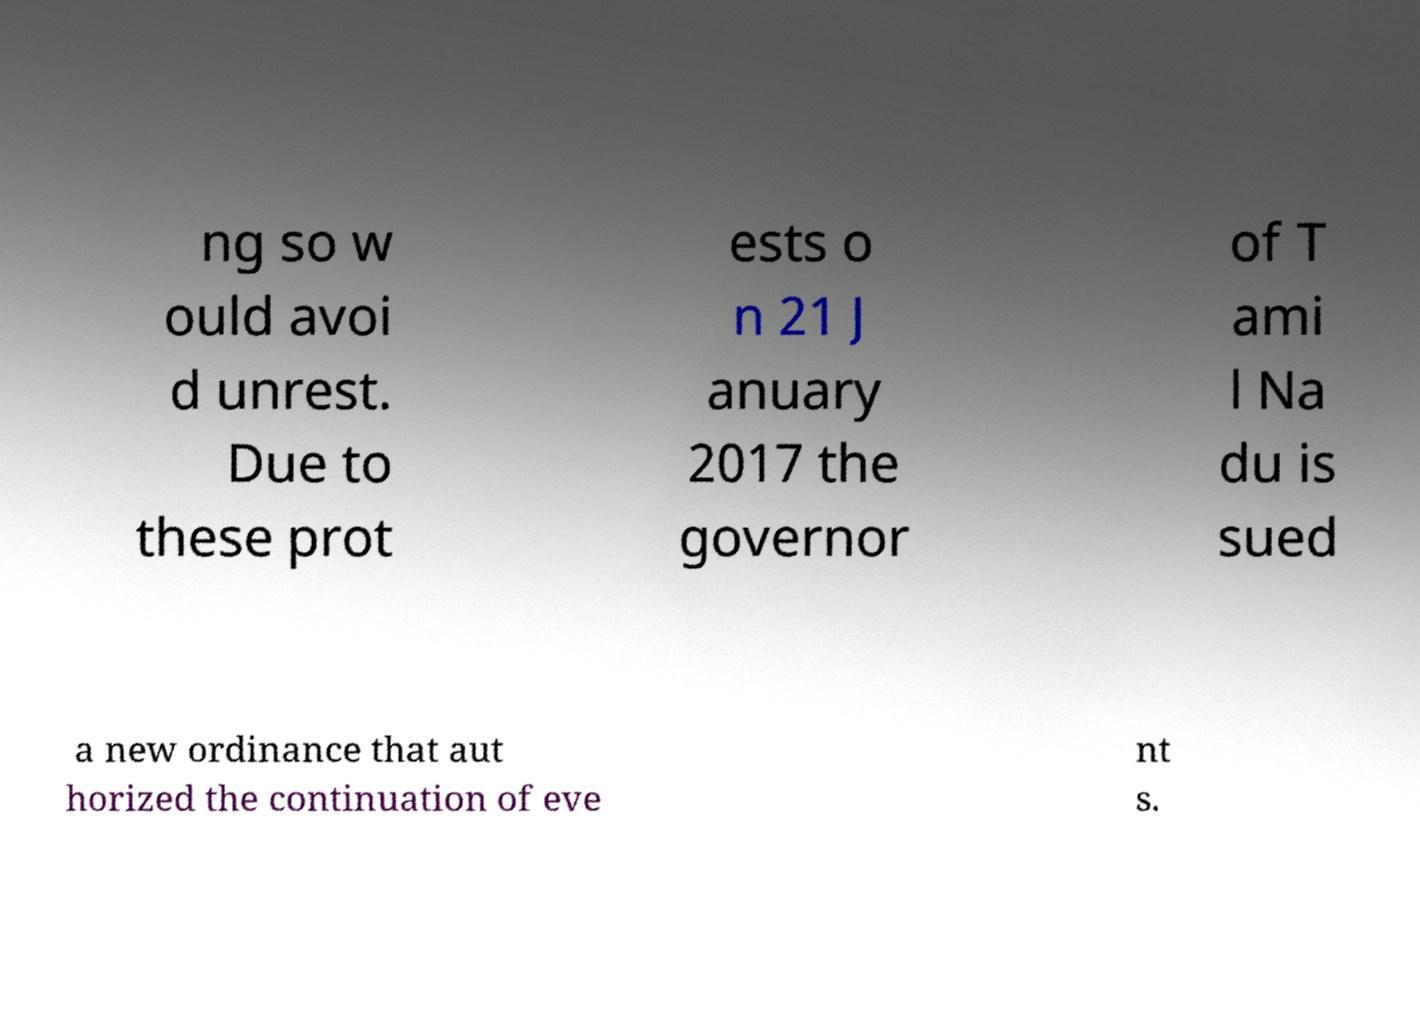Can you read and provide the text displayed in the image?This photo seems to have some interesting text. Can you extract and type it out for me? ng so w ould avoi d unrest. Due to these prot ests o n 21 J anuary 2017 the governor of T ami l Na du is sued a new ordinance that aut horized the continuation of eve nt s. 